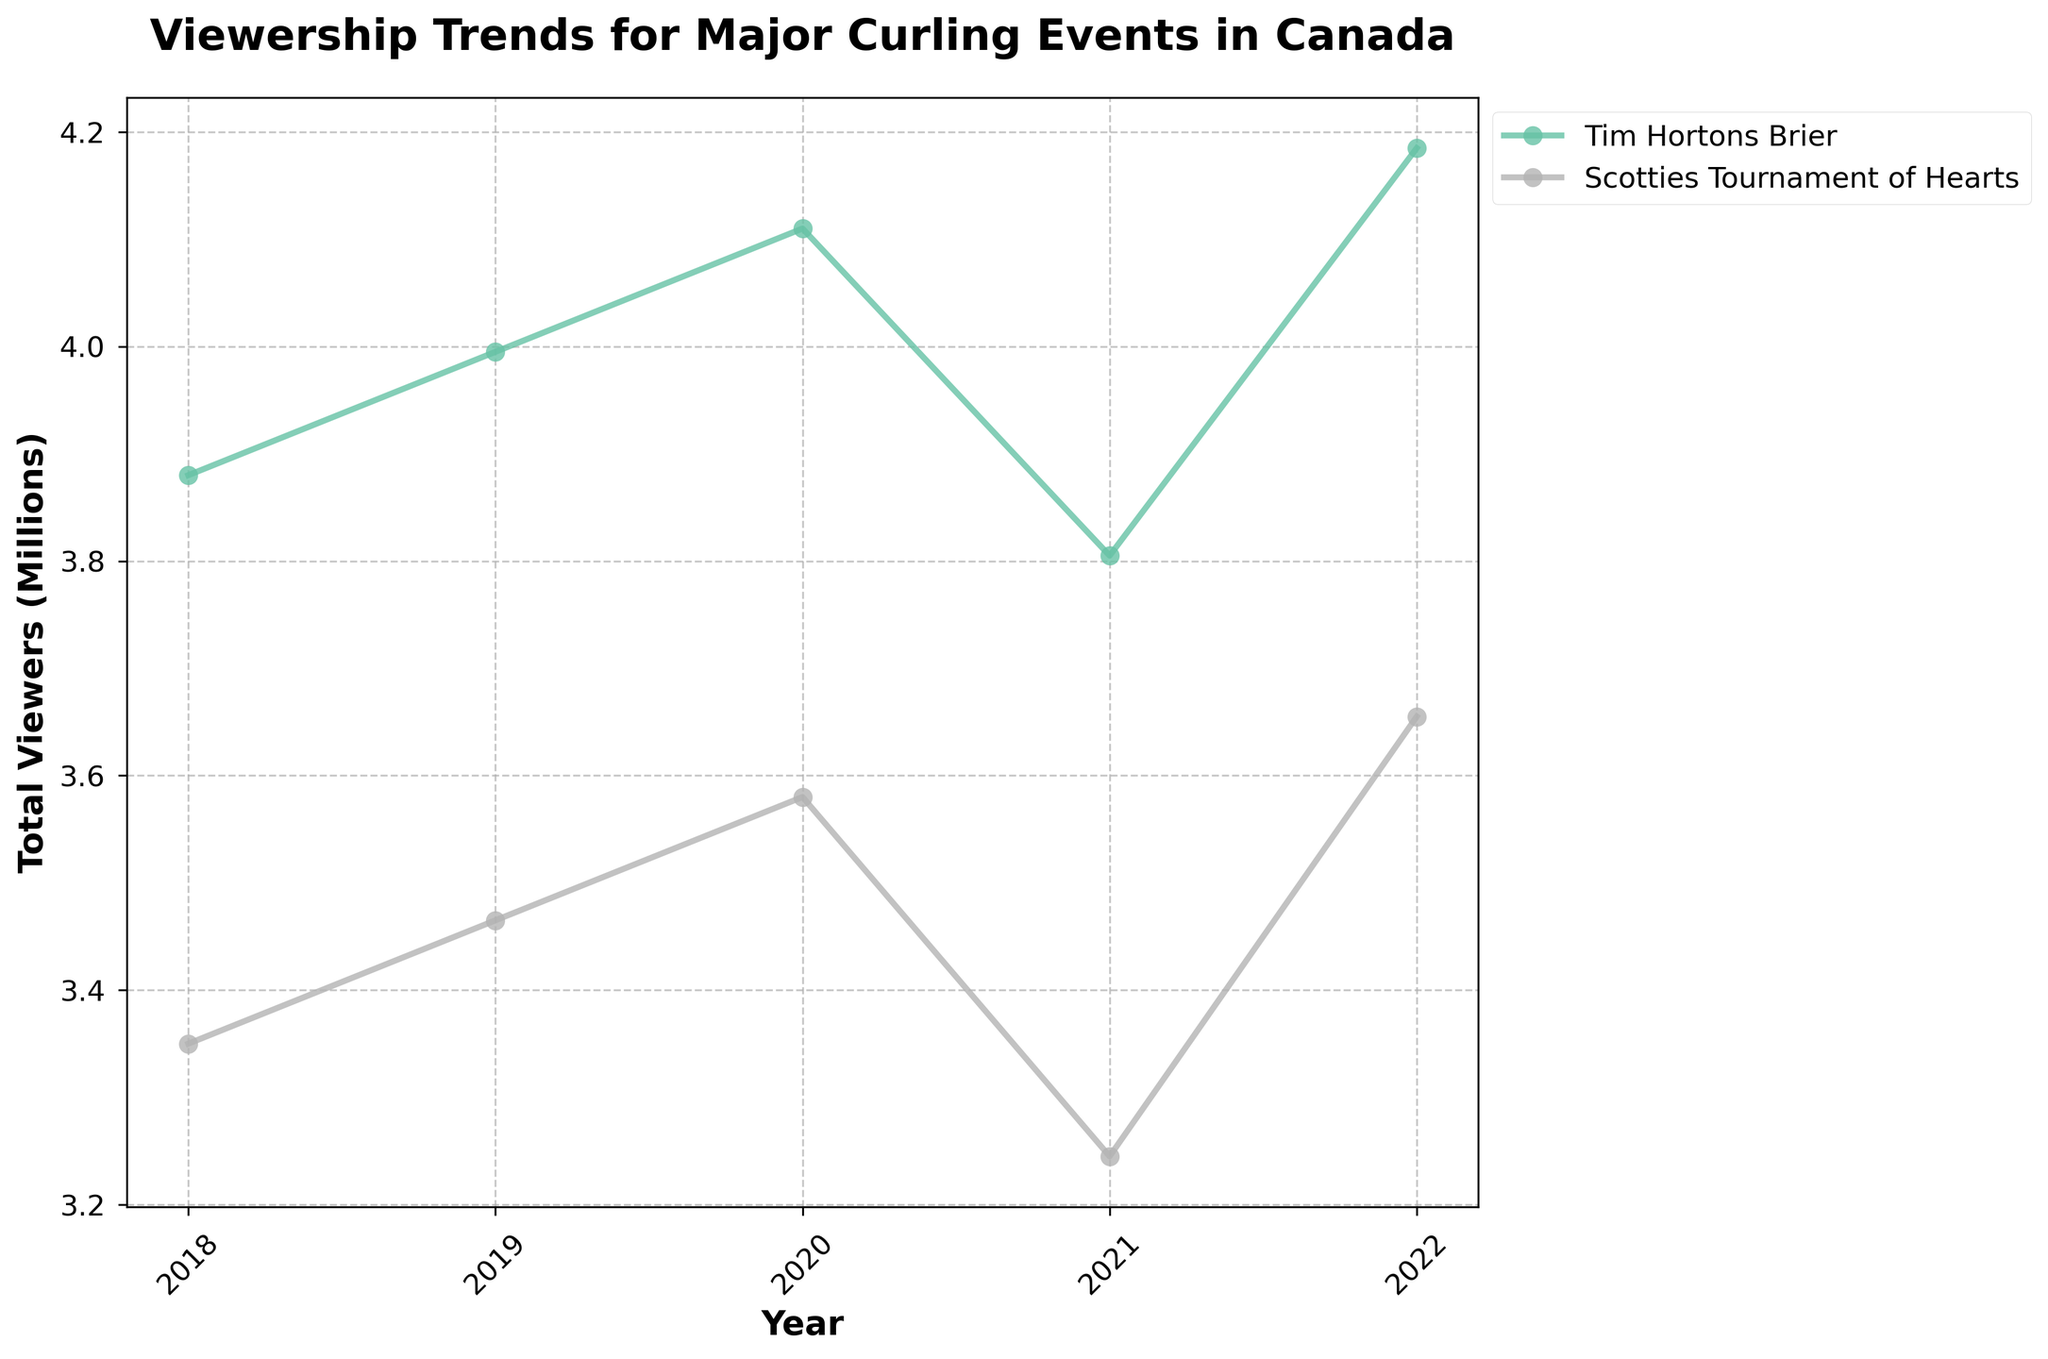What is the total number of viewers for the Tim Hortons Brier in 2020? To find the total number of viewers, sum the viewership across all age groups and regions for the Tim Hortons Brier in 2020. The viewership numbers are: 130000, 190000, 270000, 240000, 160000, 190000, 280000, 370000, 330000, 230000, 250000, 340000, 440000, 400000, 290000. Adding these up: 130000 + 190000 + 270000 + 240000 + 160000 + 190000 + 280000 + 370000 + 330000 + 230000 + 250000 + 340000 + 440000 + 400000 + 290000 = 4110000 viewers.
Answer: 4110000 How did the viewership for the Scotties Tournament of Hearts in 2021 compare with 2022? To compare the viewership, look at the total viewers for both years. For 2021, the sum of viewership across all age groups and regions for the Scotties Tournament of Hearts is: 95000 + 145000 + 200000 + 180000 + 125000 + 145000 + 215000 + 290000 + 260000 + 185000 + 195000 + 275000 + 360000 + 330000 + 245000 = 3300000 viewers. For 2022, the sum is: 115000 + 165000 + 235000 + 215000 + 145000 + 165000 + 245000 + 325000 + 295000 + 205000 + 215000 + 305000 + 395000 + 365000 + 265000 = 3900000 viewers. Comparing these sums, viewership increased from 3300000 to 3900000 viewers.
Answer: Viewership increased Which event had a higher viewership in 2019: Tim Hortons Brier or Scotties Tournament of Hearts? To determine which event had higher viewership in 2019, sum the viewership across all age groups and regions for both events. For the Tim Hortons Brier: 125000 + 185000 + 260000 + 230000 + 155000 + 185000 + 270000 + 360000 + 320000 + 225000 + 245000 + 330000 + 430000 + 390000 + 285000 = 3990000 viewers. For Scotties Tournament of Hearts: 105000 + 155000 + 220000 + 200000 + 135000 + 155000 + 230000 + 310000 + 280000 + 195000 + 205000 + 290000 + 380000 + 350000 + 255000 = 3465000 viewers. The Tim Hortons Brier had higher viewership.
Answer: Tim Hortons Brier What is the trend in viewership for the 18-34 age group in Quebec for the Scotties Tournament of Hearts from 2018 to 2022? To identify the trend, look at the viewership numbers for the 18-34 age group in Quebec for the Scotties Tournament of Hearts from 2018 to 2022. The viewership numbers are: 150000 (2018), 155000 (2019), 160000 (2020), 145000 (2021), and 165000 (2022). The viewership has shown a slight increase overall with a dip in 2021.
Answer: Increasing overall with a dip in 2021 What was the difference in total viewership between the Tim Hortons Brier in 2018 and 2021? To find the difference, calculate the total viewership for the Tim Hortons Brier in both years and then subtract one from the other. In 2018, the total viewership is: 120000 + 180000 + 250000 + 220000 + 150000 + 180000 + 260000 + 350000 + 310000 + 220000 + 240000 + 320000 + 420000 + 380000 + 280000 = 3880000 viewers. In 2021, the total viewership is: 115000 + 175000 + 245000 + 215000 + 145000 + 175000 + 255000 + 345000 + 305000 + 215000 + 235000 + 315000 + 415000 + 375000 + 275000 = 3925000 viewers. The difference is 3925000 - 3880000 = 45000 viewers.
Answer: 45000 Was there a decrease or increase in viewership for the 35-54 age group in the Prairies between Tim Hortons Brier 2018 and Scotties Tournament of Hearts 2022? Compare the viewership numbers for the 35-54 age group in the Prairies between both events. In 2018, for the Tim Hortons Brier, the viewership is 310000. In 2022, for the Scotties Tournament of Hearts, the viewership is 295000. There was a decrease from 310000 to 295000 viewers.
Answer: Decrease 